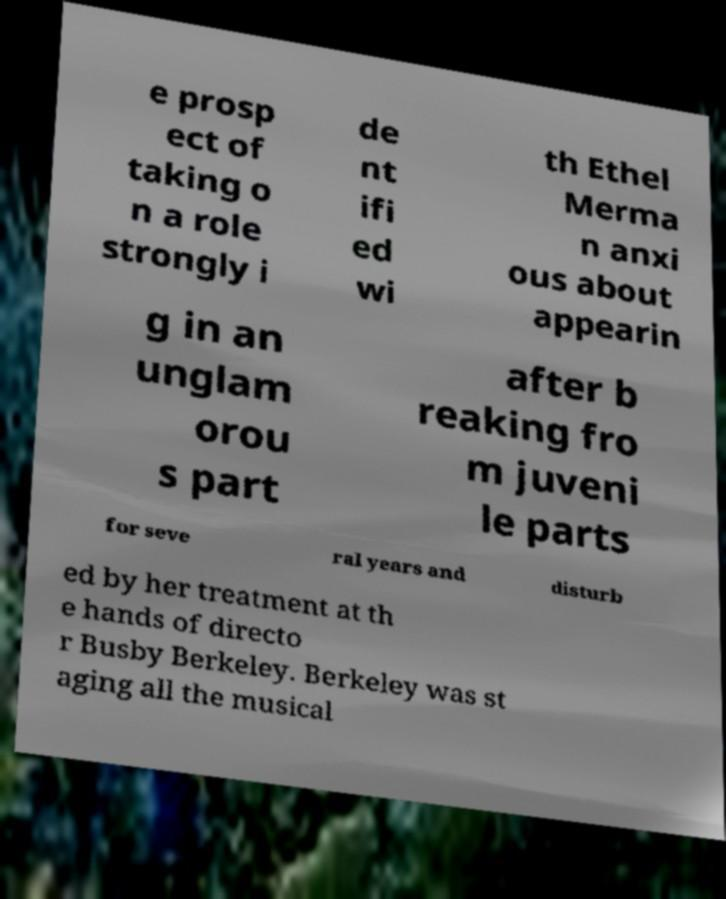Can you accurately transcribe the text from the provided image for me? e prosp ect of taking o n a role strongly i de nt ifi ed wi th Ethel Merma n anxi ous about appearin g in an unglam orou s part after b reaking fro m juveni le parts for seve ral years and disturb ed by her treatment at th e hands of directo r Busby Berkeley. Berkeley was st aging all the musical 